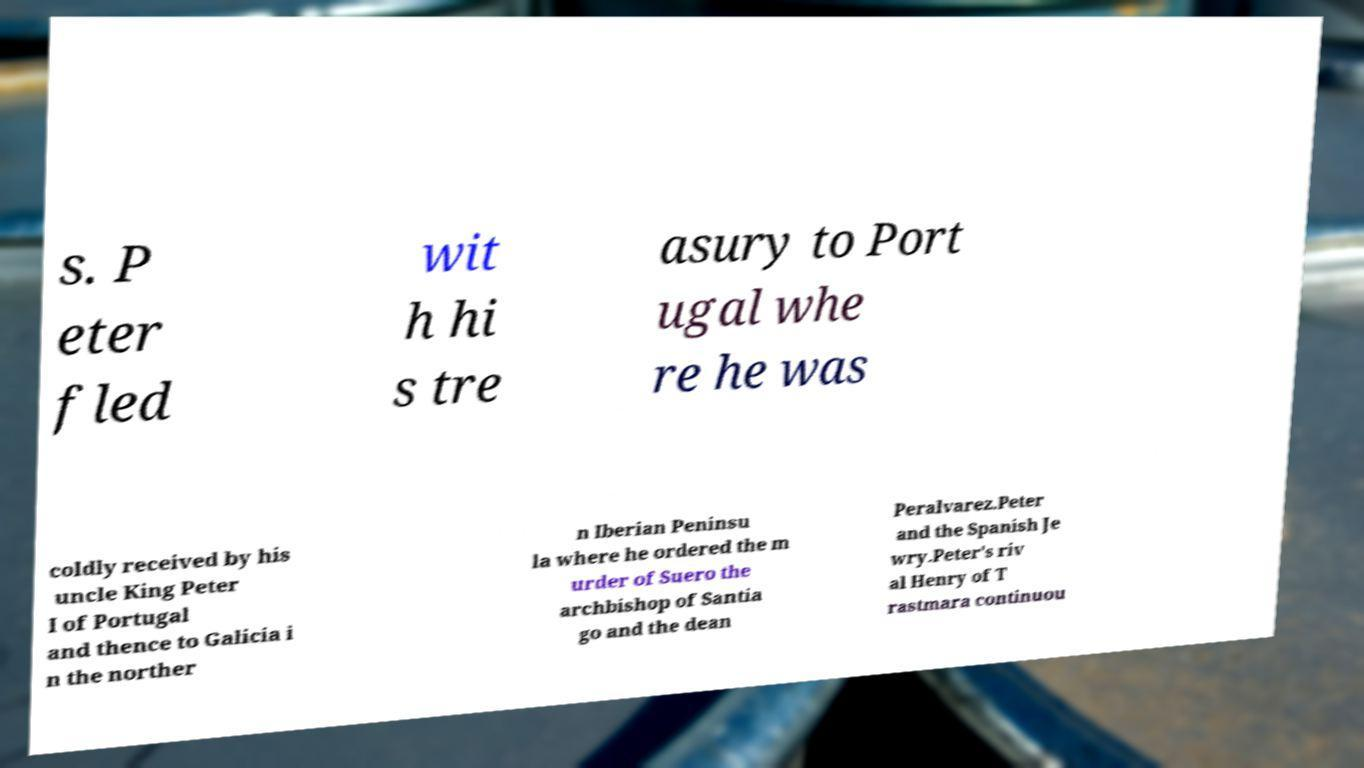Please read and relay the text visible in this image. What does it say? s. P eter fled wit h hi s tre asury to Port ugal whe re he was coldly received by his uncle King Peter I of Portugal and thence to Galicia i n the norther n Iberian Peninsu la where he ordered the m urder of Suero the archbishop of Santia go and the dean Peralvarez.Peter and the Spanish Je wry.Peter's riv al Henry of T rastmara continuou 